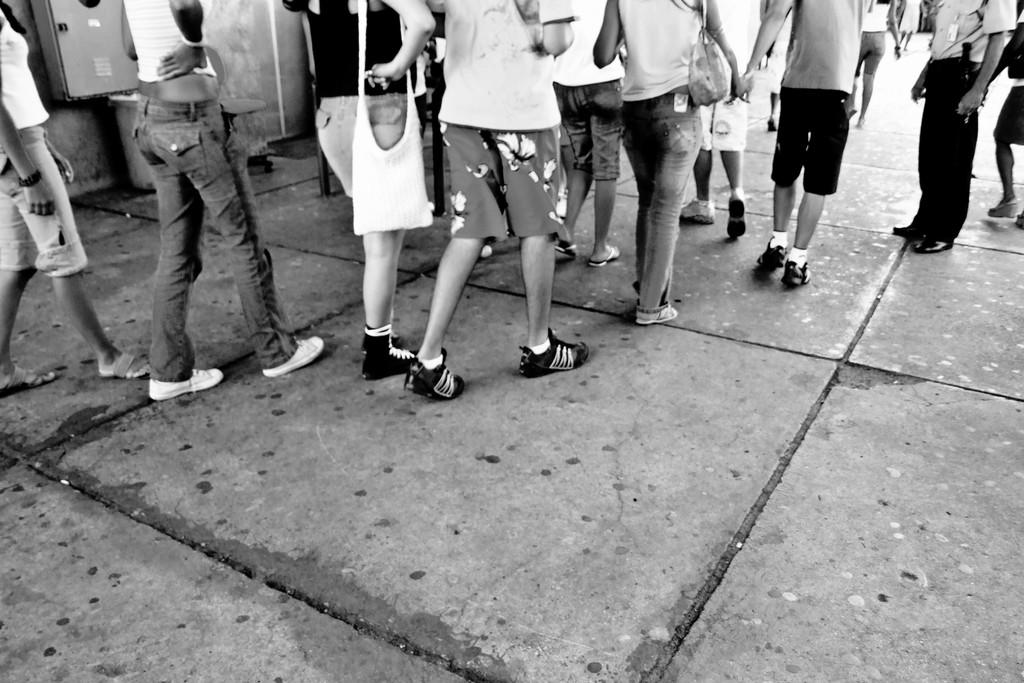What is the color scheme of the image? The image is black and white. What are the people in the image doing? Some persons are walking, and others are standing on the floor in the image. What type of tub can be seen in the image? There is no tub present in the image. How many bushes are visible in the image? There are no bushes visible in the image. 